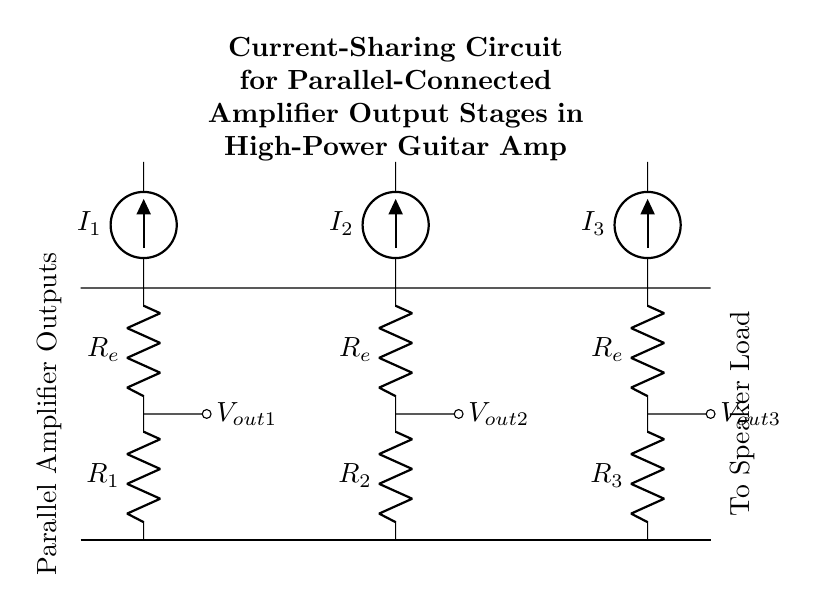What are the values of the resistors in the circuit? The circuit diagram shows three resistors labeled as R1, R2, and R3. However, the specific numerical values of these resistors are not provided in the diagram; it only names them.
Answer: R1, R2, R3 What do R_e resistors represent in this circuit? The resistors labeled R_e in this circuit are typically emitter resistors used in amplifier configurations. They serve to stabilize the operating point of the amplifier and share the output current among the amplifiers.
Answer: Emitter resistors How many amplifier stages are in the current-sharing circuit? There are three amplifiers in the circuit as depicted by the three sets of resistors and current sources representing the output stages of the amplifier.
Answer: Three What is the purpose of the current sources in the circuit? The current sources, labeled I1, I2, and I3, are providing the necessary currents to each of the parallel amplifier output stages. They ensure that each amplifier receives the appropriate current for proper functioning.
Answer: Provide current If all resistances are equal, how would the total current be divided? In a current divider, if all resistances are equal, the total current will be evenly divided among the output stages. In this circuit, that would mean I_total divided by 3 for each amplifier since there are three identical branches.
Answer: Evenly divided What is the voltage at the output terminals? The output voltages V_out1, V_out2, and V_out3 are taken across the output terminals of each amplifier stage; however, the actual output voltage values need to be calculated based on the specific currents through each resistor, which are not specified in the diagram.
Answer: V_out1, V_out2, V_out3 